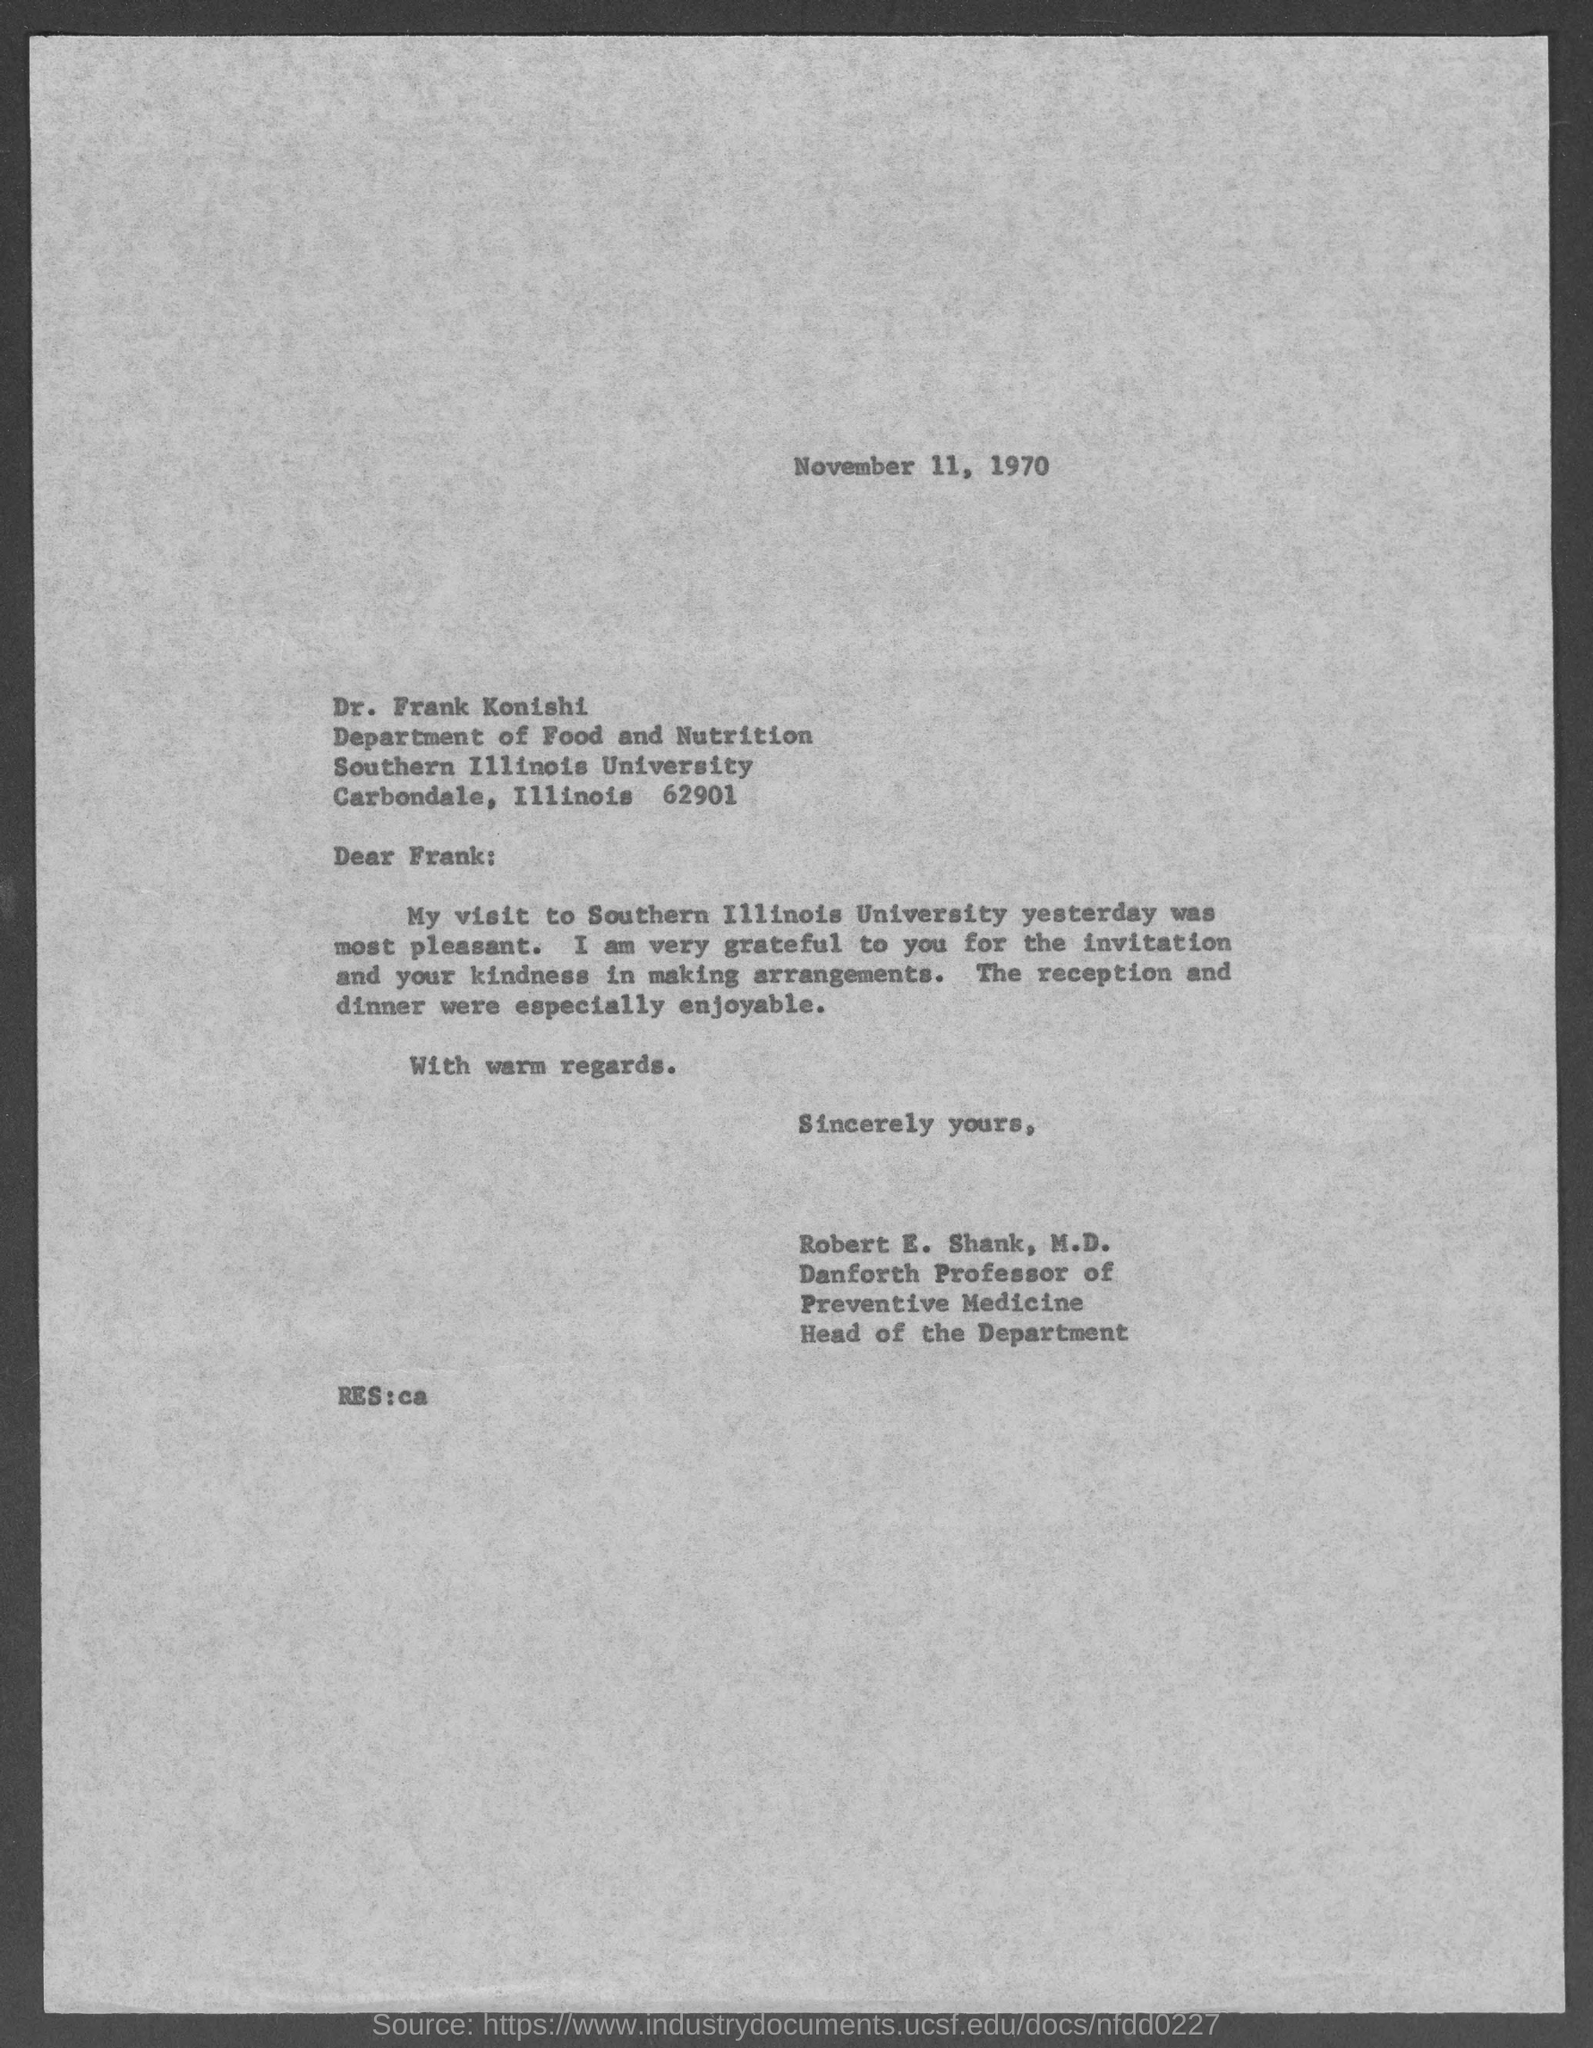Give some essential details in this illustration. The document mentions that the date is November 11, 1970. The postal address of Southern Illinois University is located in Carbondale, Illinois, and is specifically located at 1260 Lincoln Drive, Carbondale, Illinois 62901. This letter is addressed to Dr. Frank Konishi. The letter was written by Robert E. Shank, M.D. The head of the Department is Robert E. Shank, M.D. 